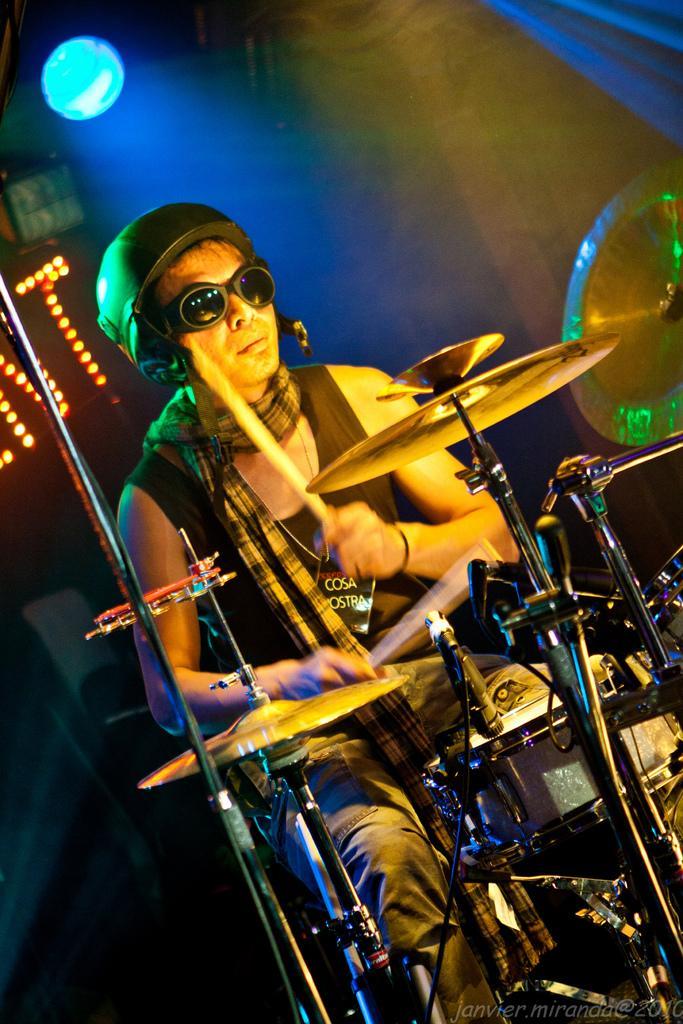Can you describe this image briefly? In this image there is a person playing drums. 